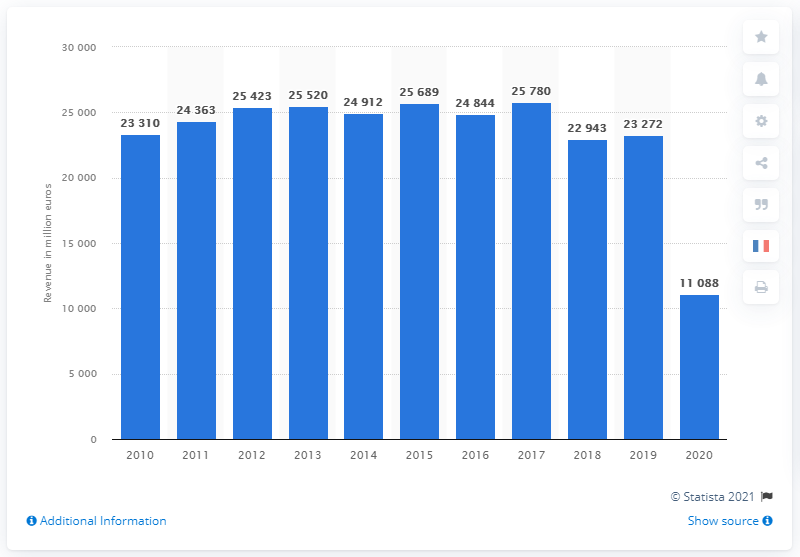Point out several critical features in this image. In 2019, the turnover of Air France-KLM was 23,272. 